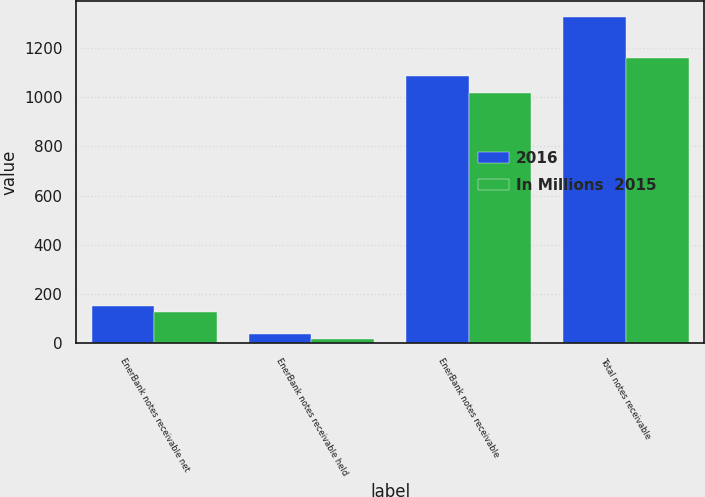Convert chart to OTSL. <chart><loc_0><loc_0><loc_500><loc_500><stacked_bar_chart><ecel><fcel>EnerBank notes receivable net<fcel>EnerBank notes receivable held<fcel>EnerBank notes receivable<fcel>Total notes receivable<nl><fcel>2016<fcel>151<fcel>39<fcel>1088<fcel>1326<nl><fcel>In Millions  2015<fcel>128<fcel>16<fcel>1017<fcel>1161<nl></chart> 